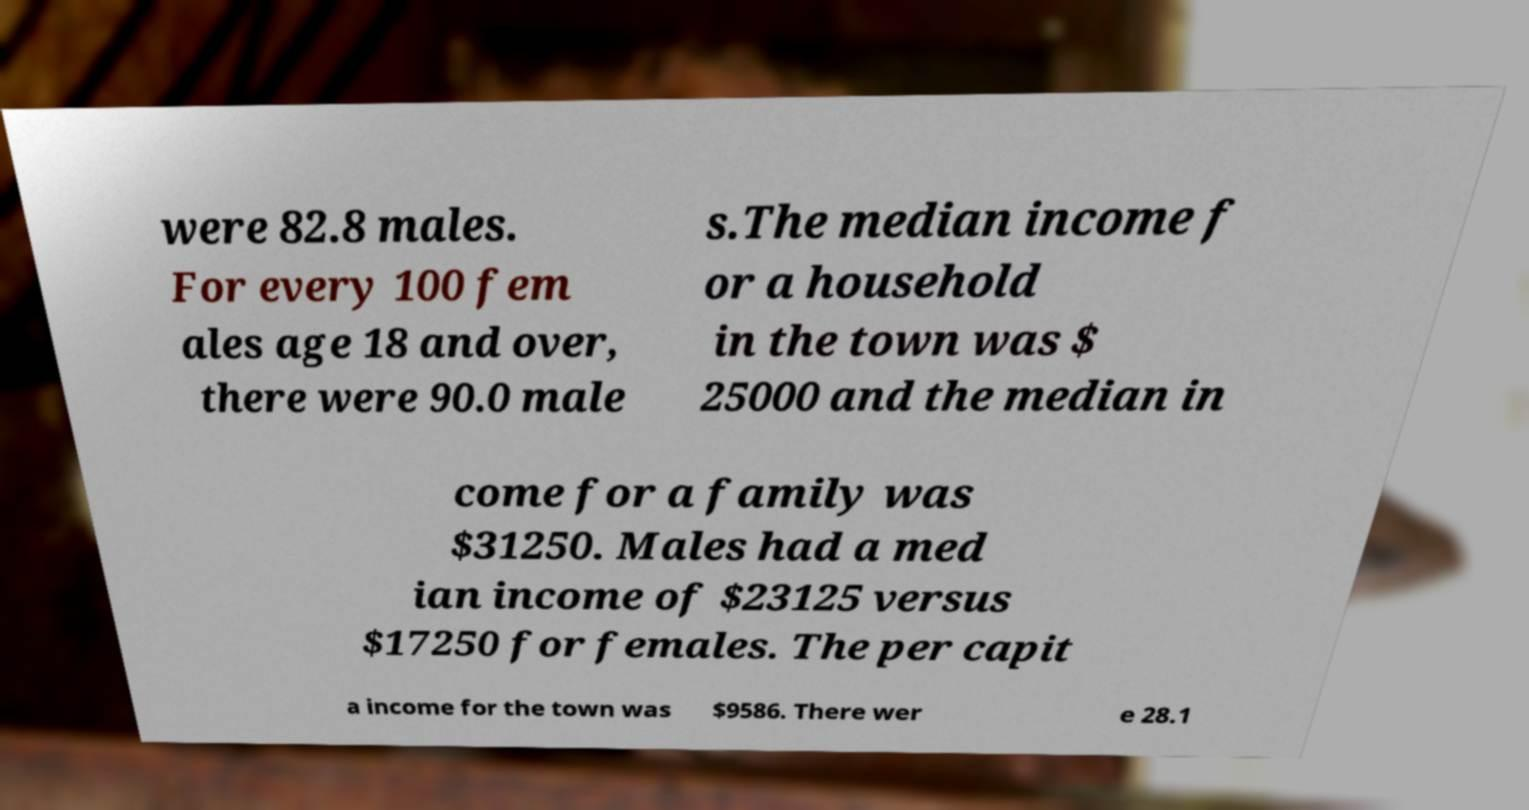Please read and relay the text visible in this image. What does it say? were 82.8 males. For every 100 fem ales age 18 and over, there were 90.0 male s.The median income f or a household in the town was $ 25000 and the median in come for a family was $31250. Males had a med ian income of $23125 versus $17250 for females. The per capit a income for the town was $9586. There wer e 28.1 